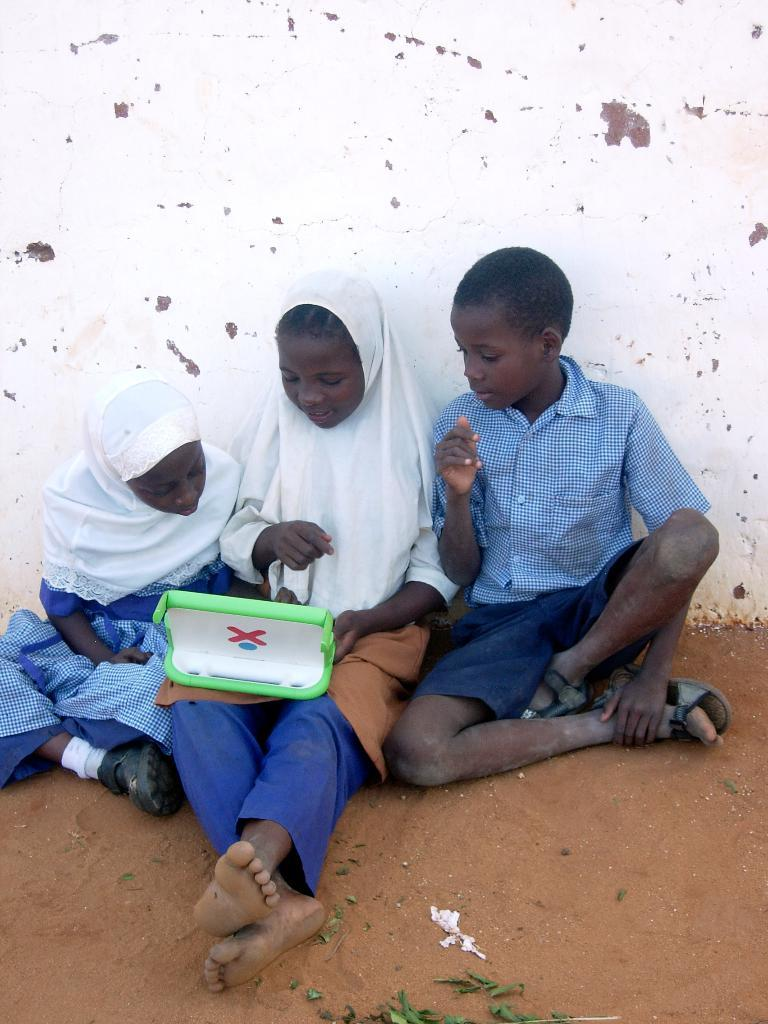How many kids are sitting on the ground in the image? There are three kids sitting on the ground in the center of the image. What is the color of the soil in the foreground of the image? There is red soil in the foreground of the image. What can be seen in the background of the image? There is a well in the background of the image. What type of basket is hanging from the moon in the image? There is no moon or basket present in the image. 